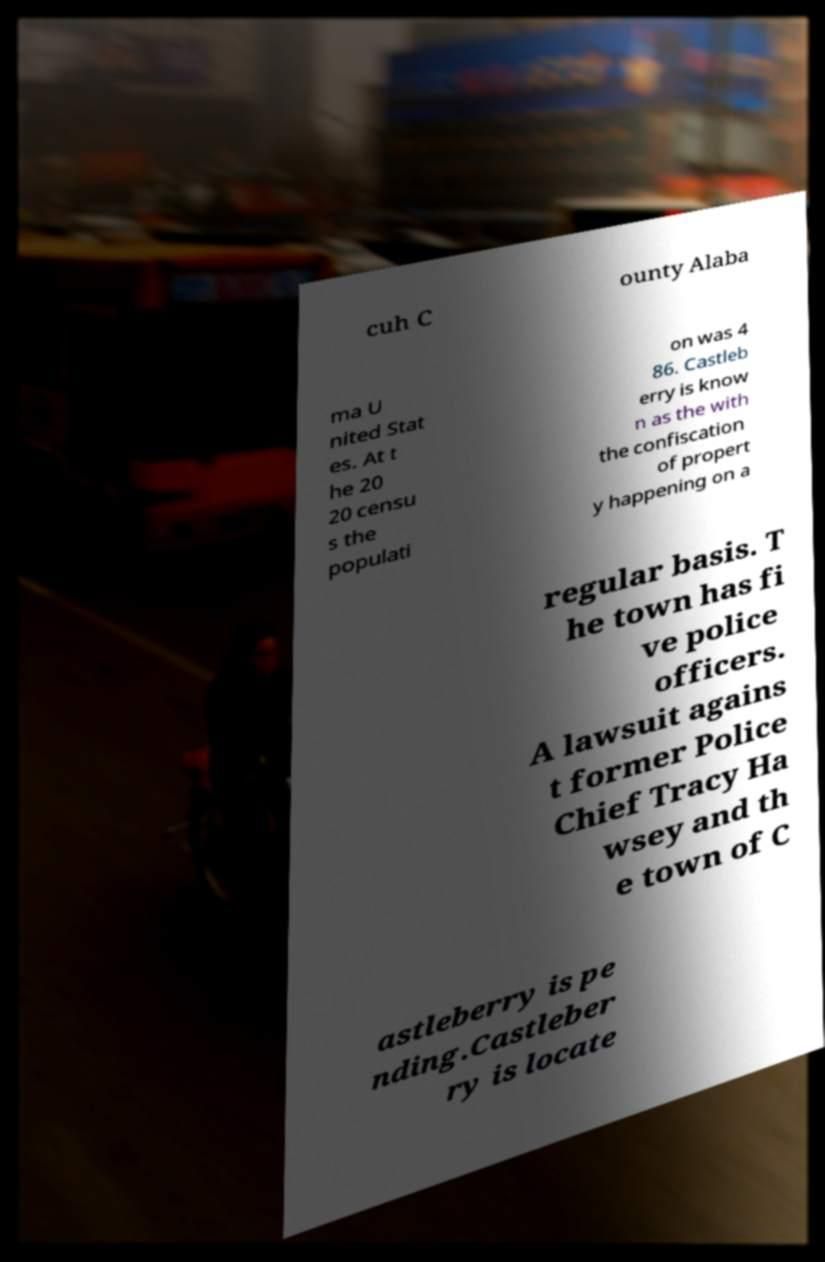Could you extract and type out the text from this image? cuh C ounty Alaba ma U nited Stat es. At t he 20 20 censu s the populati on was 4 86. Castleb erry is know n as the with the confiscation of propert y happening on a regular basis. T he town has fi ve police officers. A lawsuit agains t former Police Chief Tracy Ha wsey and th e town of C astleberry is pe nding.Castleber ry is locate 